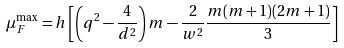<formula> <loc_0><loc_0><loc_500><loc_500>\mu _ { F } ^ { \max } = h \left [ \left ( q ^ { 2 } - \frac { 4 } { d ^ { 2 } } \right ) m - \frac { 2 } { w ^ { 2 } } \frac { m ( m + 1 ) ( 2 m + 1 ) } { 3 } \right ]</formula> 